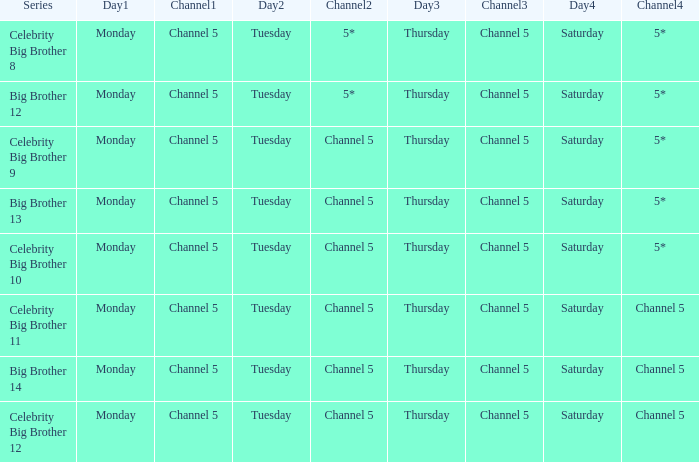Which Thursday does big brother 13 air? Channel 5. 